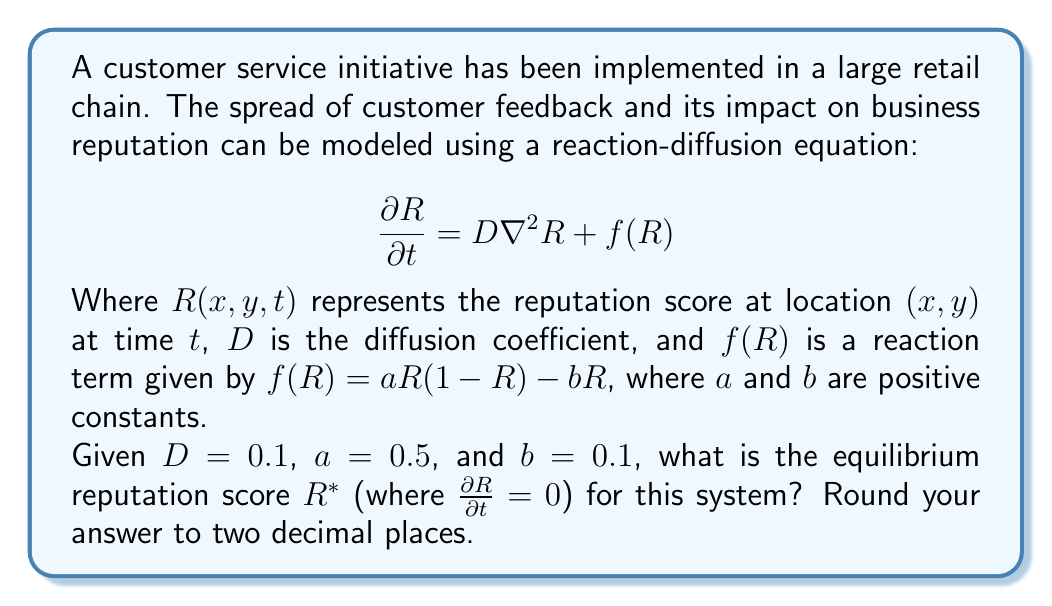Can you answer this question? To solve this problem, we need to follow these steps:

1) At equilibrium, the reputation score doesn't change with time, so $\frac{\partial R}{\partial t} = 0$.

2) Also, at equilibrium, we assume the reputation is uniform across all locations, so $\nabla^2R = 0$.

3) Therefore, our equation at equilibrium becomes:

   $$0 = 0 + f(R^*)$$

4) Substituting the given reaction term:

   $$0 = aR^*(1-R^*) - bR^*$$

5) Expanding this equation:

   $$0 = aR^* - aR^{*2} - bR^*$$
   $$0 = R^*(a - aR^* - b)$$

6) This equation has two solutions: $R^* = 0$ or $a - aR^* - b = 0$

7) We're interested in the non-zero solution, so let's solve $a - aR^* - b = 0$:

   $$a - aR^* - b = 0$$
   $$a - b = aR^*$$
   $$R^* = \frac{a-b}{a}$$

8) Now we can substitute the given values $a = 0.5$ and $b = 0.1$:

   $$R^* = \frac{0.5 - 0.1}{0.5} = \frac{0.4}{0.5} = 0.8$$

9) Rounding to two decimal places, we get $R^* = 0.80$.

This equilibrium reputation score represents the long-term reputation of the business if the current conditions persist.
Answer: $R^* = 0.80$ 